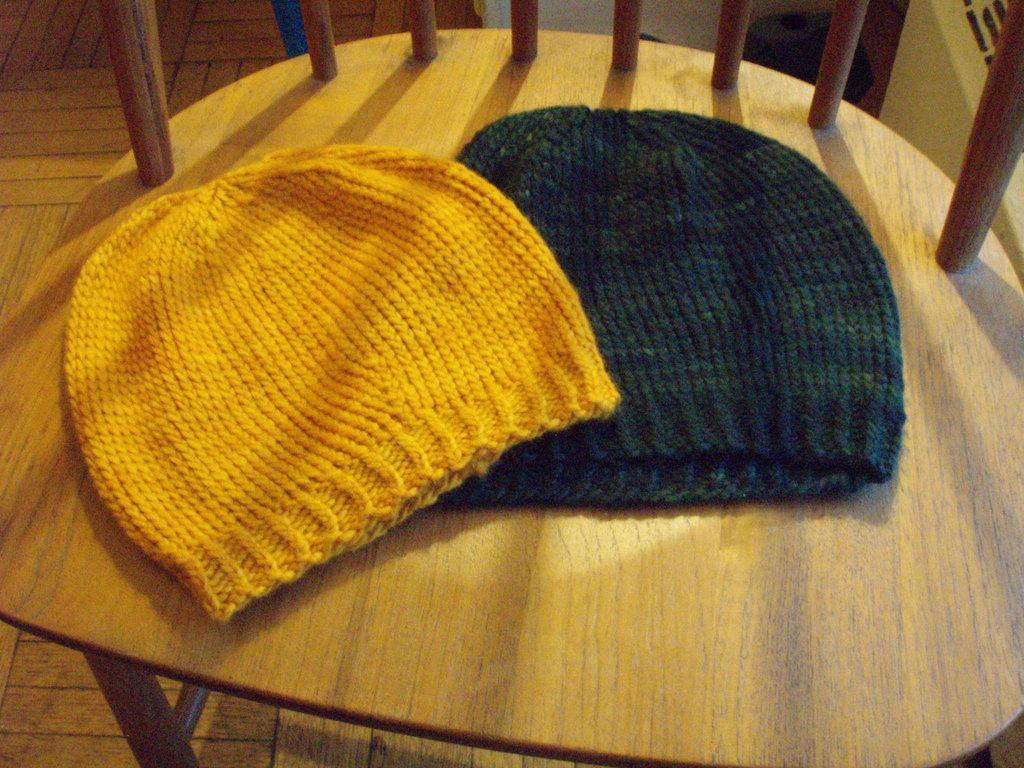What type of clothing items are in the image? There are beanies in the image. Where are the beanies located? The beanies are on a chair. What is the chair resting on in the image? The chair is placed on the floor. What is the fuel efficiency of the beanies in the image? Beanies do not have fuel efficiency, as they are clothing items and not vehicles. 